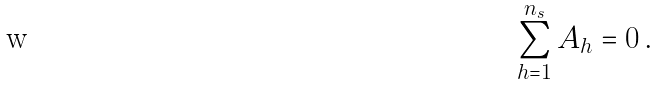<formula> <loc_0><loc_0><loc_500><loc_500>\sum _ { h = 1 } ^ { n _ { s } } A _ { h } = 0 \, .</formula> 